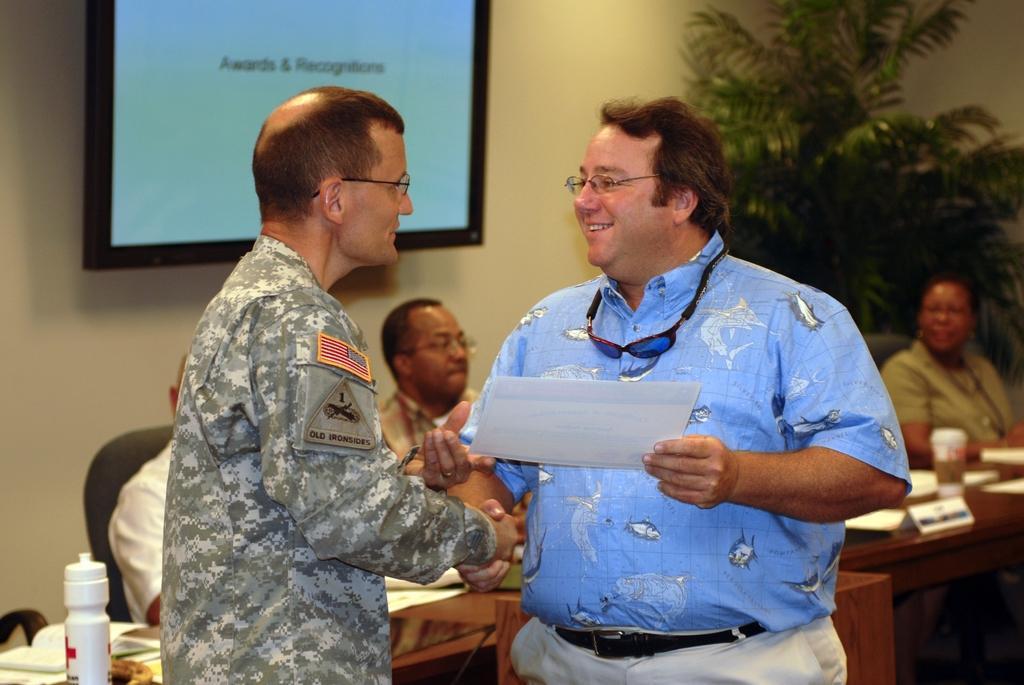Could you give a brief overview of what you see in this image? In this image there are two persons standing and shaking their hands and holding paper in his hand, in the background there are people sitting on chairs, in front of them there is a table on that table there are papers, bottles, in the background there is a tree, a wall for that wall there is a tv. 